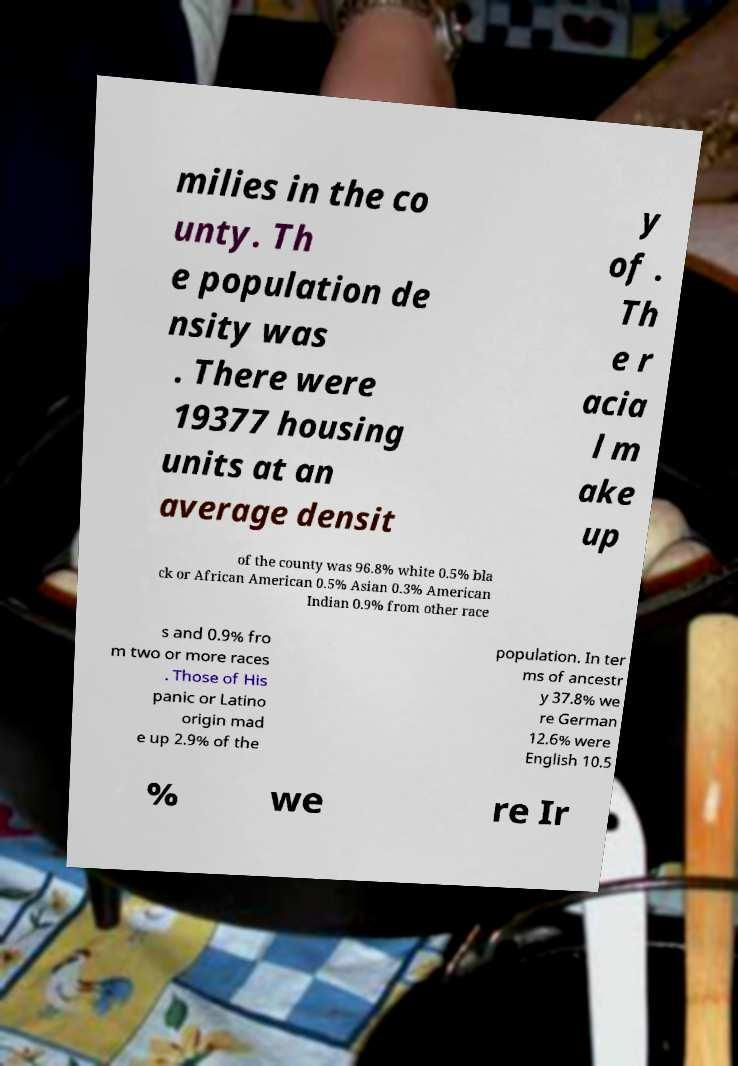I need the written content from this picture converted into text. Can you do that? milies in the co unty. Th e population de nsity was . There were 19377 housing units at an average densit y of . Th e r acia l m ake up of the county was 96.8% white 0.5% bla ck or African American 0.5% Asian 0.3% American Indian 0.9% from other race s and 0.9% fro m two or more races . Those of His panic or Latino origin mad e up 2.9% of the population. In ter ms of ancestr y 37.8% we re German 12.6% were English 10.5 % we re Ir 